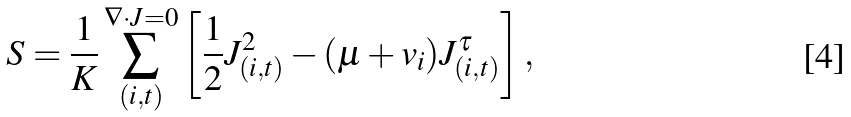<formula> <loc_0><loc_0><loc_500><loc_500>S = \frac { 1 } { K } \sum _ { ( i , t ) } ^ { \nabla \cdot J = 0 } \left [ \frac { 1 } { 2 } { J } ^ { 2 } _ { ( i , t ) } - ( \mu + v _ { i } ) J ^ { \tau } _ { ( i , t ) } \right ] ,</formula> 